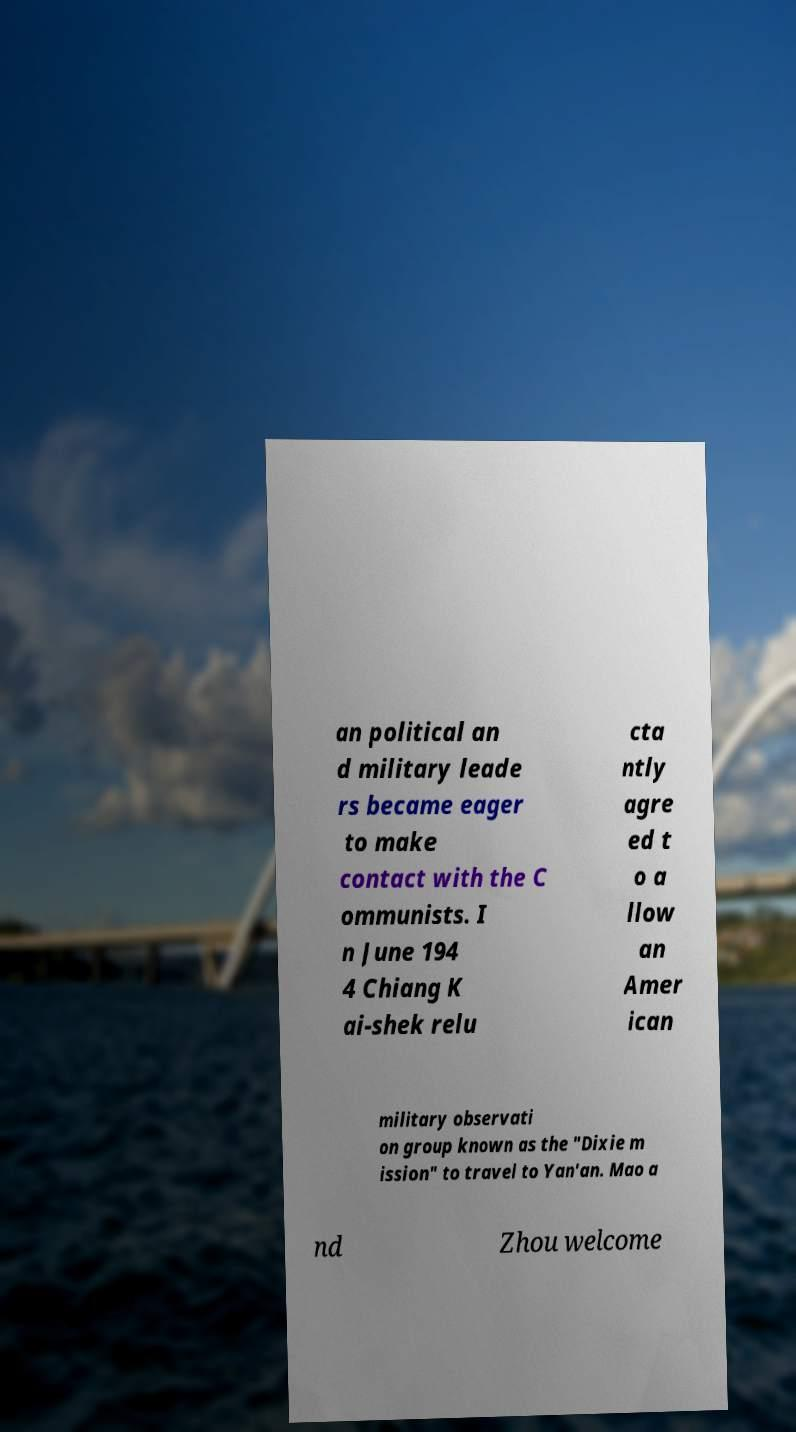Can you accurately transcribe the text from the provided image for me? an political an d military leade rs became eager to make contact with the C ommunists. I n June 194 4 Chiang K ai-shek relu cta ntly agre ed t o a llow an Amer ican military observati on group known as the "Dixie m ission" to travel to Yan'an. Mao a nd Zhou welcome 